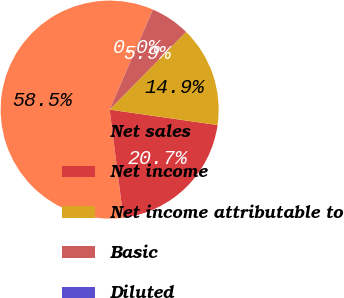Convert chart. <chart><loc_0><loc_0><loc_500><loc_500><pie_chart><fcel>Net sales<fcel>Net income<fcel>Net income attributable to<fcel>Basic<fcel>Diluted<nl><fcel>58.5%<fcel>20.74%<fcel>14.89%<fcel>5.86%<fcel>0.01%<nl></chart> 